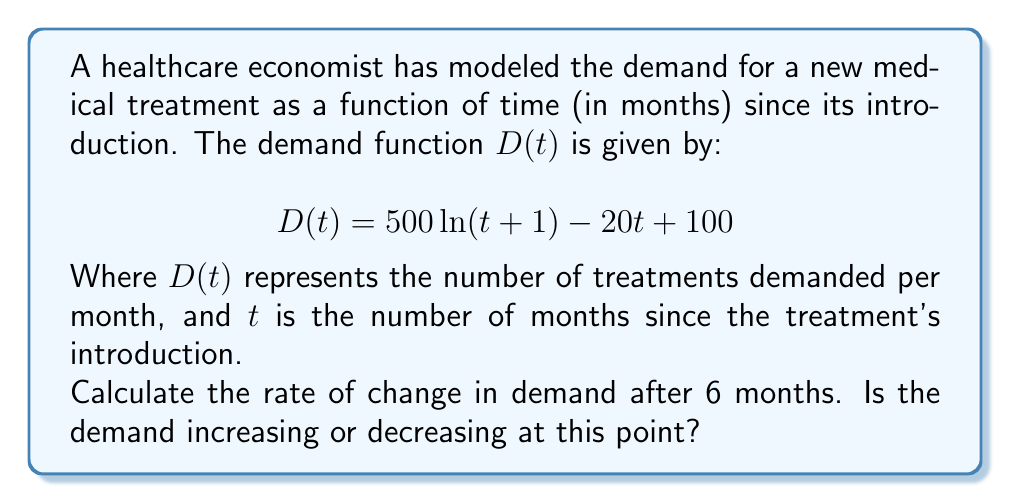Solve this math problem. To solve this problem, we need to follow these steps:

1) The rate of change in demand is represented by the derivative of the demand function $D(t)$ with respect to time $t$.

2) Let's calculate the derivative $D'(t)$:

   $$D'(t) = \frac{d}{dt}[500\ln(t+1) - 20t + 100]$$

   Using the rules of differentiation:
   
   $$D'(t) = 500 \cdot \frac{1}{t+1} - 20$$

3) Now that we have the derivative, we can calculate the rate of change at $t=6$ by substituting this value:

   $$D'(6) = 500 \cdot \frac{1}{6+1} - 20$$
   
   $$D'(6) = 500 \cdot \frac{1}{7} - 20$$
   
   $$D'(6) = \frac{500}{7} - 20$$
   
   $$D'(6) = 71.43 - 20 = 51.43$$

4) To determine if the demand is increasing or decreasing, we look at the sign of $D'(6)$:
   
   Since $D'(6) = 51.43 > 0$, the demand is increasing at $t=6$ months.
Answer: The rate of change in demand after 6 months is approximately 51.43 treatments per month, and the demand is increasing at this point. 